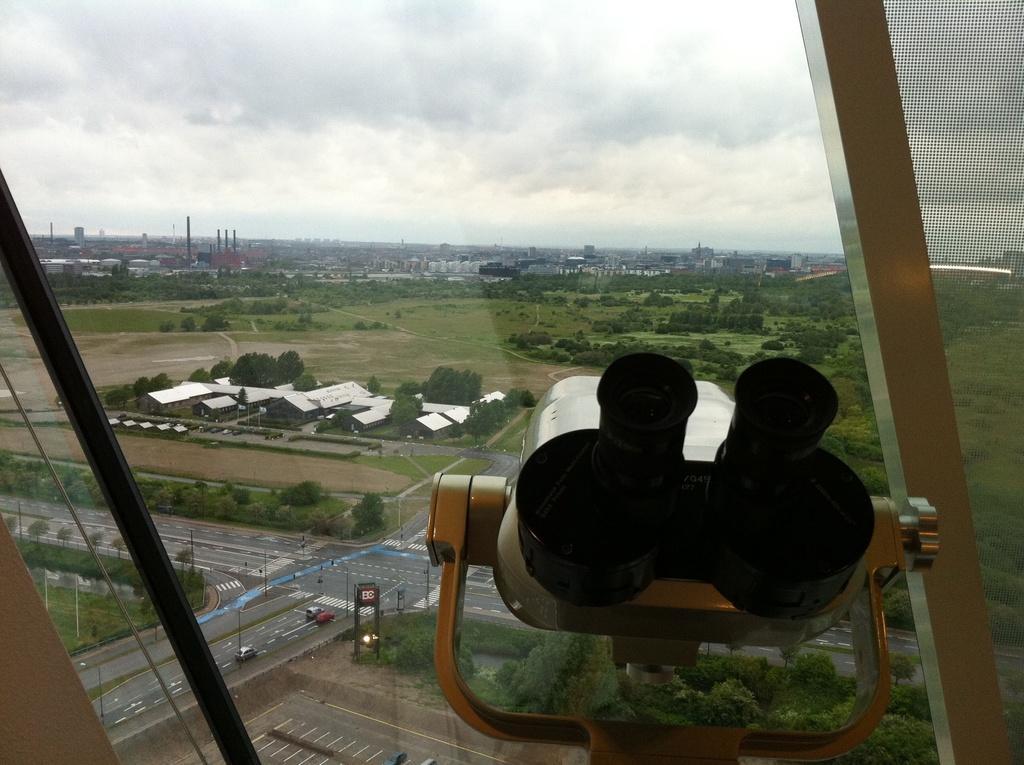Can you describe this image briefly? In this picture there is a telescope and a glass window, outside the window there are trees, buildings, roads, vehicles and fields. In the background there are buildings and trees. Sky is cloudy. 